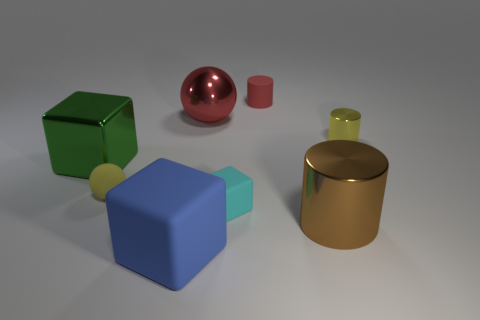There is a large thing that is both behind the blue rubber block and in front of the tiny rubber sphere; what shape is it?
Give a very brief answer. Cylinder. There is a metallic cylinder behind the metal cylinder in front of the tiny yellow metallic cylinder that is on the right side of the big shiny cylinder; what is its color?
Offer a very short reply. Yellow. Is the number of blue things to the right of the yellow cylinder less than the number of yellow matte things?
Ensure brevity in your answer.  Yes. There is a tiny yellow object on the left side of the yellow shiny cylinder; is it the same shape as the red object on the left side of the tiny red matte cylinder?
Your response must be concise. Yes. How many things are either metal objects that are behind the green thing or large metallic cylinders?
Offer a very short reply. 3. There is a tiny thing that is the same color as the large ball; what material is it?
Make the answer very short. Rubber. Is there a tiny ball right of the green metal thing that is in front of the small yellow object right of the red matte object?
Make the answer very short. Yes. Are there fewer yellow matte things behind the small red matte thing than big blue matte objects that are in front of the small yellow cylinder?
Your answer should be very brief. Yes. The tiny cylinder that is made of the same material as the large green thing is what color?
Keep it short and to the point. Yellow. What color is the thing that is to the right of the shiny thing that is in front of the cyan cube?
Your answer should be compact. Yellow. 